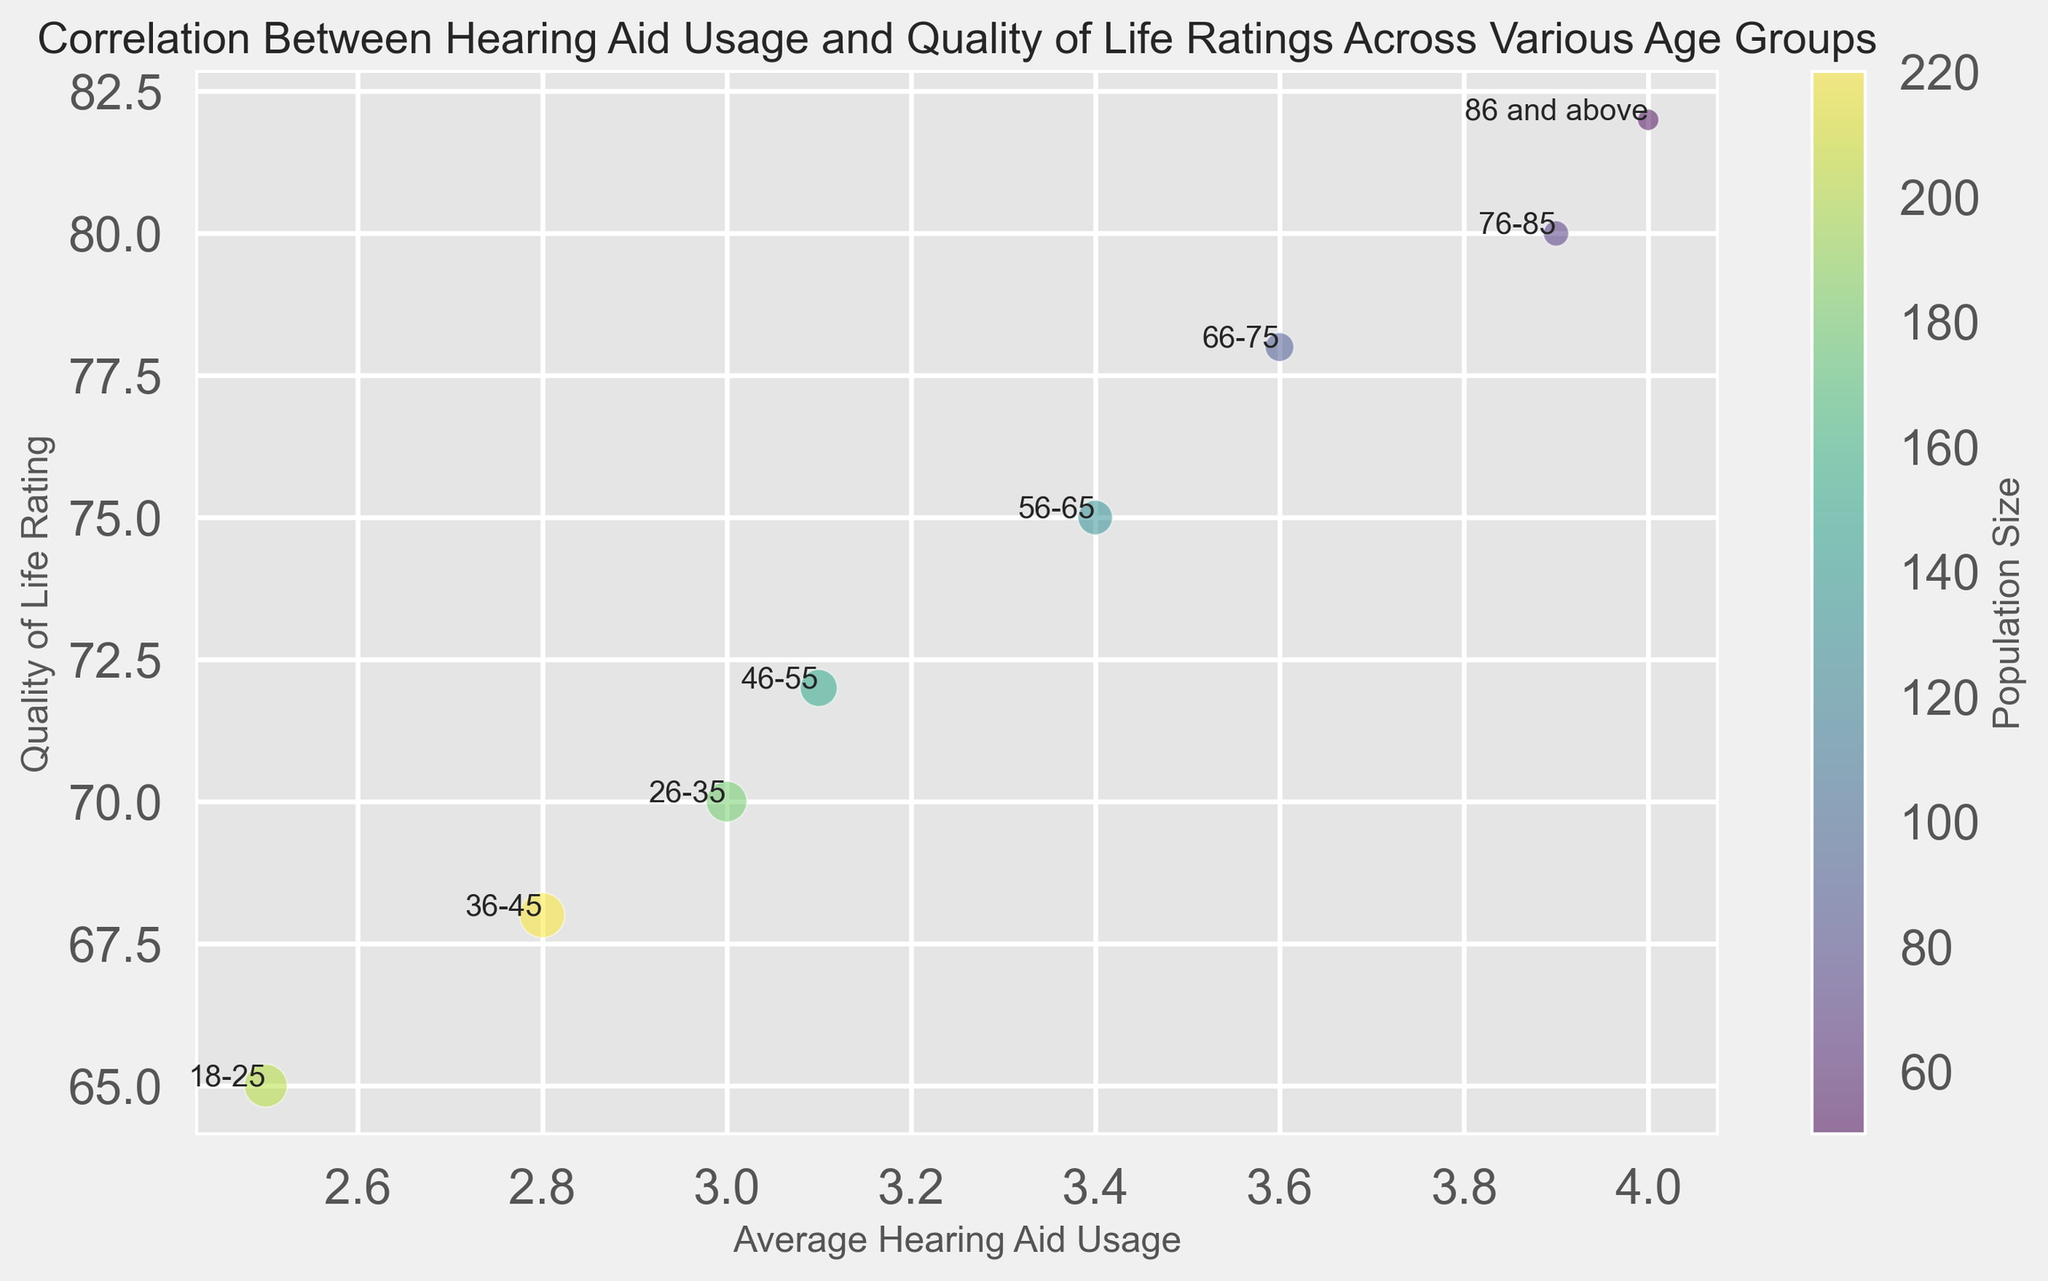Which age group exhibits the highest average hearing aid usage? The bubble chart shows the average hearing aid usage along the x-axis. The age group "86 and above" is located farthest to the right, indicating it has the highest average hearing aid usage.
Answer: 86 and above Which age group has the lowest quality of life rating? The chart places quality of life ratings along the y-axis. The age group "18-25" is positioned lowest on this axis, indicating the lowest quality of life rating.
Answer: 18-25 What is the relationship between hearing aid usage and quality of life ratings across the age groups? Observing the bubbles from left to right, both average hearing aid usage and quality of life ratings tend to increase. This suggests a positive correlation between hearing aid usage and quality of life ratings as age increases.
Answer: Positive correlation How does the size of the bubble represent population size, and which age group has the largest population? Bubble size correlates with population size, and the chart's legend confirms this. The largest bubble is for the "36-45" age group, indicating it has the largest population.
Answer: 36-45 Which two age groups have the smallest difference in quality of life ratings? By comparing the y-axis positions, "18-25" (65) and "36-45" (68) are closest, with just a 3-point difference in their quality of life ratings.
Answer: 18-25 and 36-45 What is the average quality of life rating for age groups above 75? To find the average, add the quality of life ratings for "76-85" (80) and "86 and above" (82), which totals 162, then divide by 2, resulting in an average of 81.
Answer: 81 Which age group has the smallest bubble, and what does this signify about its population size? The smallest bubble is for the "86 and above" age group, implying it has the smallest population size.
Answer: 86 and above Does any age group have an equal population size and quality of life rating? Observing the figure, no age group has a bubble size (population) and position on the y-axis (quality of life rating) that match.
Answer: No 